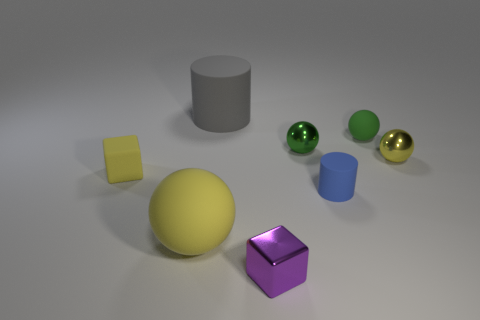What number of other things are there of the same size as the yellow shiny sphere?
Keep it short and to the point. 5. How big is the metal ball to the right of the green matte thing?
Provide a short and direct response. Small. What material is the large object to the right of the large matte object that is on the left side of the large matte thing that is behind the tiny blue rubber thing?
Your answer should be compact. Rubber. Is the tiny yellow matte object the same shape as the purple thing?
Make the answer very short. Yes. How many metal things are either small red objects or small blue objects?
Offer a very short reply. 0. What number of small yellow cylinders are there?
Your response must be concise. 0. What color is the metal block that is the same size as the blue cylinder?
Provide a short and direct response. Purple. Do the green metal thing and the blue thing have the same size?
Your response must be concise. Yes. There is a small object that is the same color as the rubber cube; what is its shape?
Your response must be concise. Sphere. Does the green matte ball have the same size as the rubber ball that is to the left of the small purple block?
Provide a short and direct response. No. 